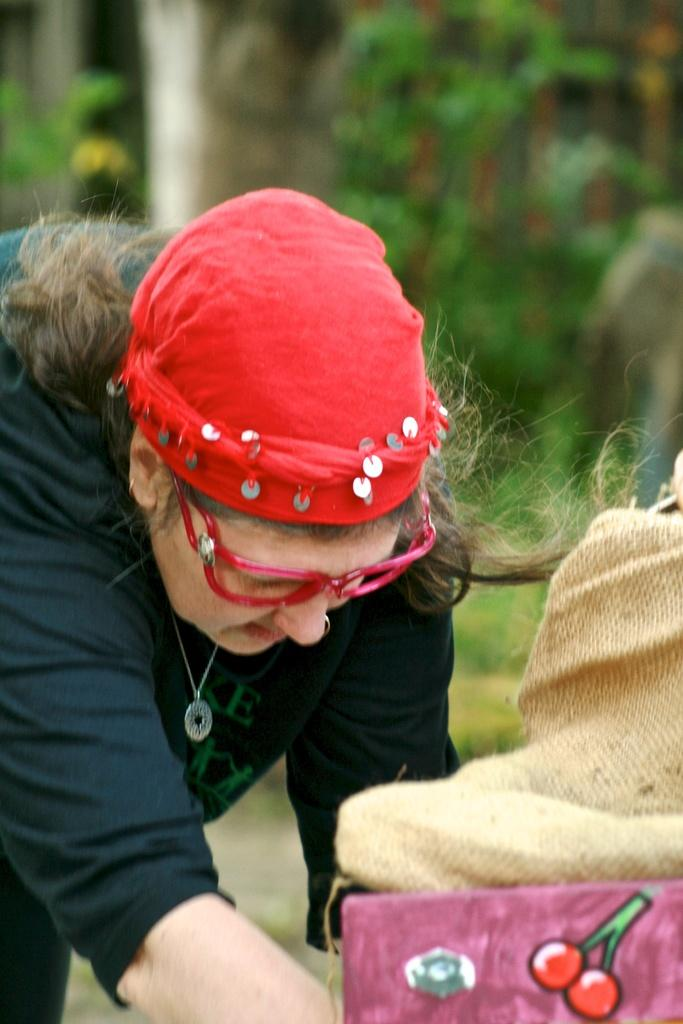Who is the main subject in the image? There is a woman in the center of the image. What is located in the front of the image? There is an object in the front of the image. What color is the object? The object is pink in color. What is on top of the object? There is a jute bag on the object. How would you describe the background of the image? The background of the image is blurry. How many pizzas are being held by the woman in the image? There are no pizzas visible in the image; the woman is not holding any. What type of quarter is depicted on the object in the image? There is no quarter present in the image; the object is pink and has a jute bag on top. 